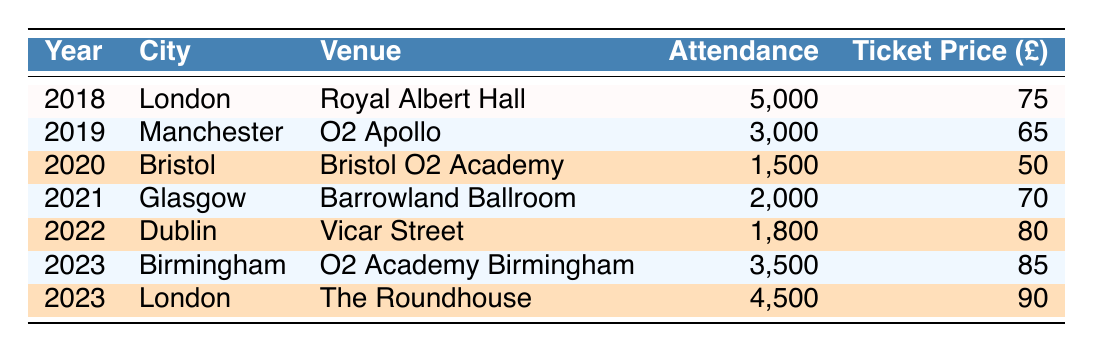What was the total attendance at Jarvis Cocker concerts in 2022? The attendance for the concert in Dublin in 2022 was 1,800. This is the only concert listed for that year. Therefore, the total attendance is simply 1,800.
Answer: 1,800 Which concert had the highest ticket price? The concert in London at The Roundhouse in 2023 had a ticket price of £90, which is higher than any other concert's ticket price listed in the table.
Answer: £90 What is the average ticket price across all concerts? The ticket prices are £75, £65, £50, £70, £80, £85, and £90. Adding these gives £75 + £65 + £50 + £70 + £80 + £85 + £90 = £515. There are 7 concerts, so the average ticket price is £515 / 7 = £73.57.
Answer: £73.57 Did attendance decrease from 2018 to 2020? The attendance was 5,000 in 2018 and decreased to 1,500 in 2020. Since 1,500 is less than 5,000, attendance did indeed decrease.
Answer: Yes What city hosted the concert with the lowest attendance? The concert in Bristol in 2020 had the lowest recorded attendance of 1,500 compared to all other concerts listed.
Answer: Bristol How much more expensive was the ticket in 2023 at The Roundhouse compared to the ticket in 2020? The ticket price at The Roundhouse in 2023 was £90, and the ticket price in 2020 at Bristol O2 Academy was £50. The difference is £90 - £50 = £40.
Answer: £40 In which year did Jarvis Cocker have concerts in two different cities? In 2023, Jarvis Cocker performed in both Birmingham and London, which are two different cities.
Answer: 2023 What was the total attendance across all concerts in 2023? The attendance for the Birmingham concert in 2023 was 3,500, and the attendance for the London concert in 2023 was 4,500. Adding these gives 3,500 + 4,500 = 8,000.
Answer: 8,000 How many concerts had an attendance of over 3,000? The concerts in London (5,000 in 2018), Manchester (3,000 in 2019), and London (4,500 in 2023) all had attendance figures over 3,000, totaling 3 concerts.
Answer: 3 Was there any concert with an attendance below 2,000? Yes, the concert in Bristol in 2020 had an attendance of 1,500, which is below 2,000.
Answer: Yes 